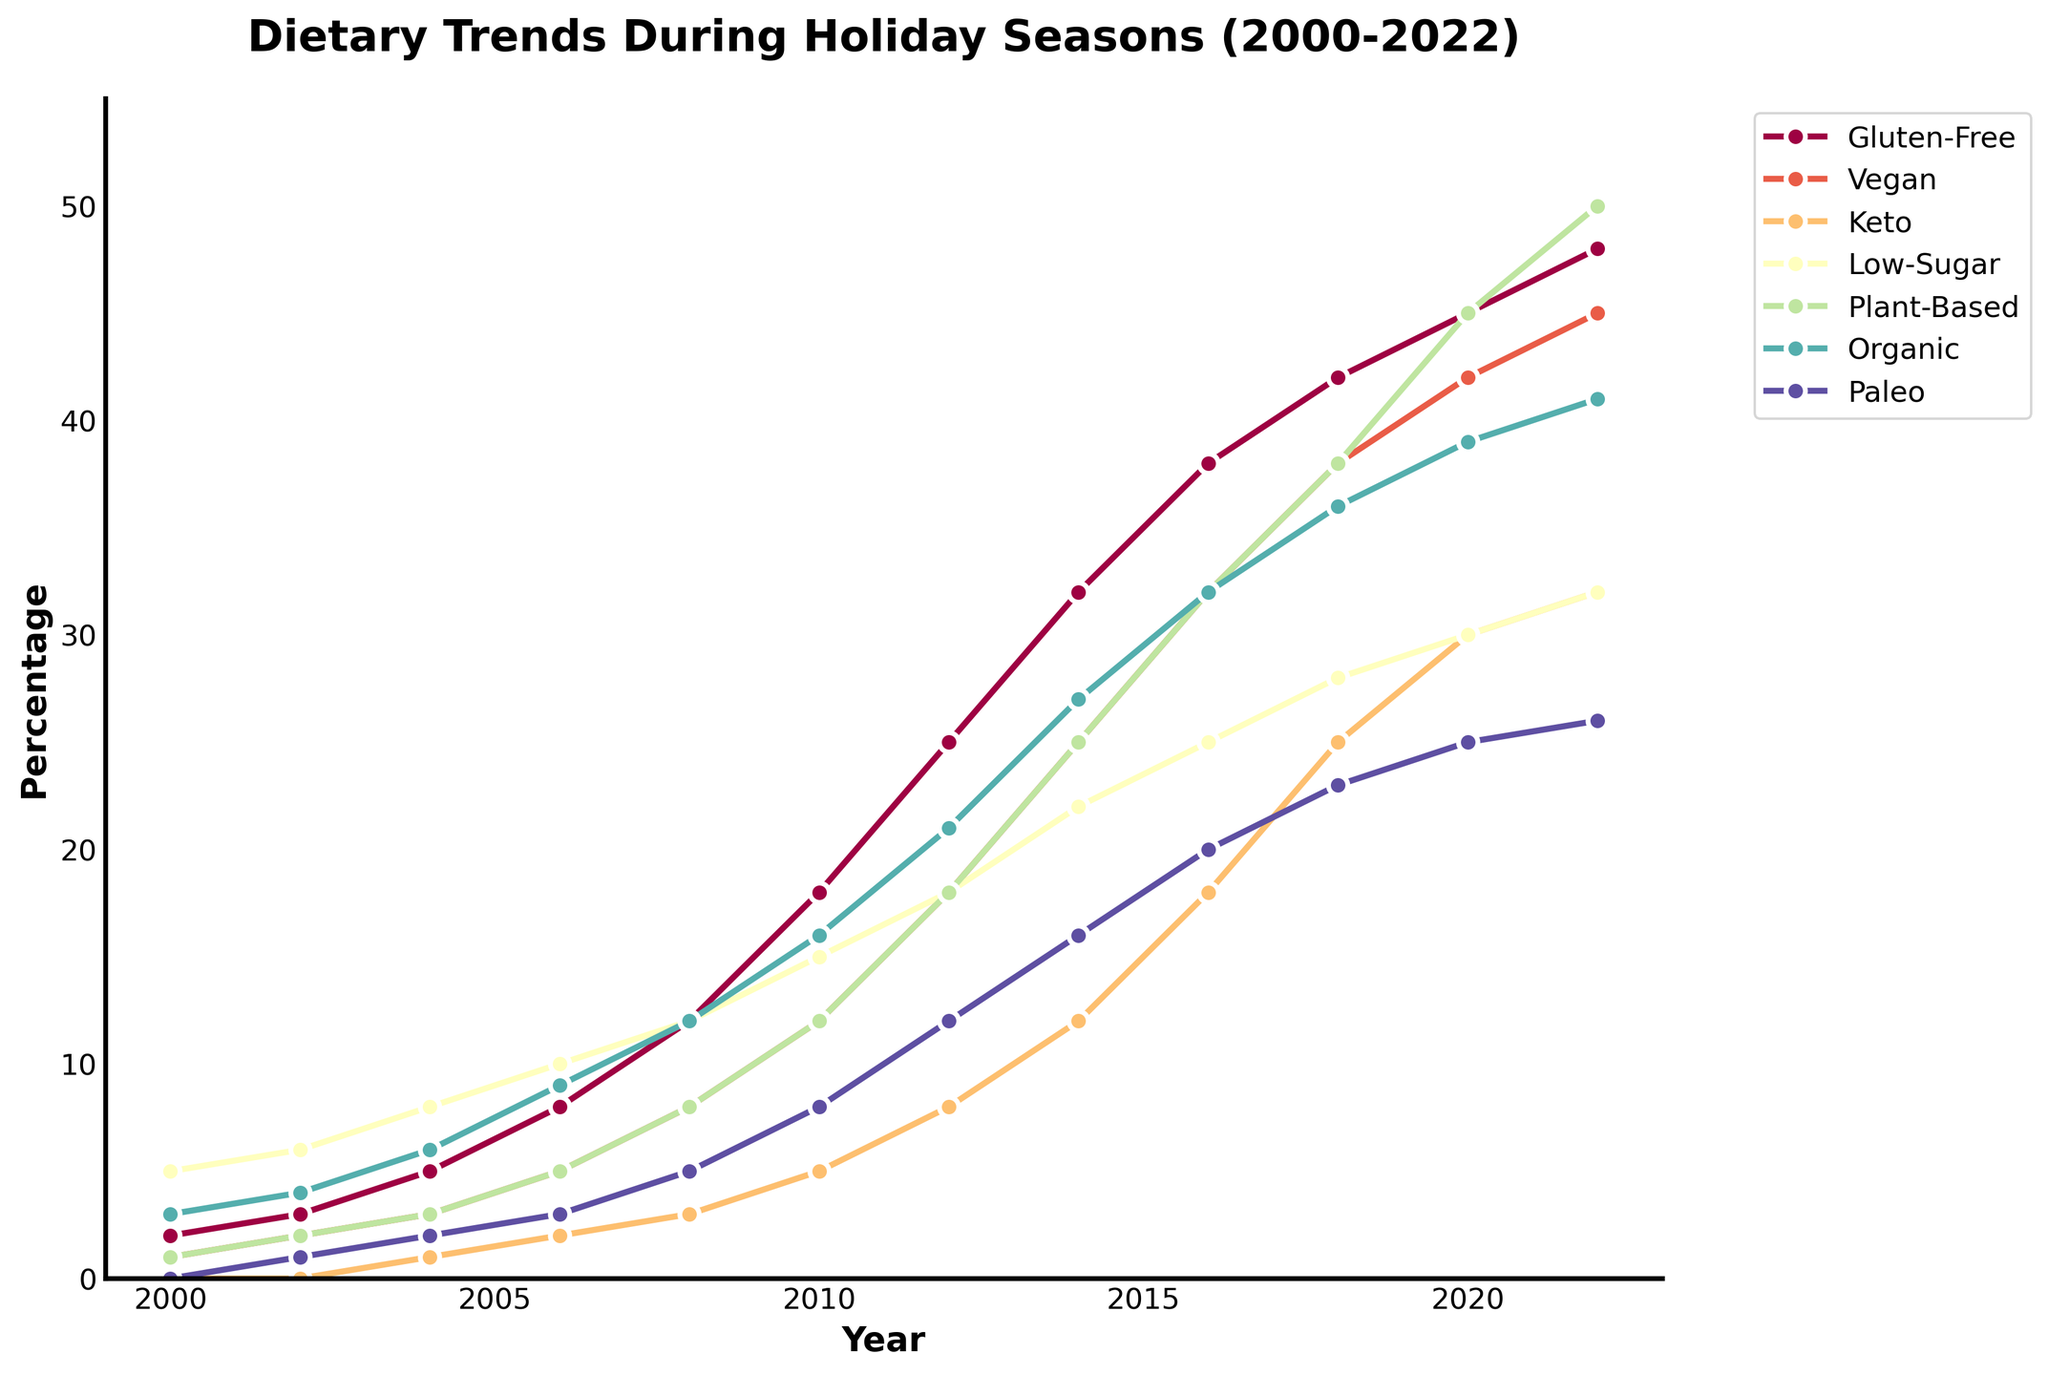What year did the Gluten-Free trend surpass 40%? The figure shows the Gluten-Free trend rising steadily, and it surpasses the 40% mark around 2018. Look for the point where the Gluten-Free line crosses above 40%.
Answer: 2018 Which dietary restriction showed the greatest increase from 2000 to 2022? By comparing the initial and final percentages of each restriction from the figure, the most significant increase is seen in the Plant-Based trend (from 1% in 2000 to 50% in 2022).
Answer: Plant-Based In which year did the Vegan trend reach the same percentage as the Low-Sugar trend in 2010? The Low-Sugar trend is approximately 15% in 2010. Check the Vegan line to find the year it first reaches 15%.
Answer: 2012 Which dietary preference maintained a consistent upward trend without any significant decline throughout the given period? Observing the lines in the figure, the Gluten-Free trend shows a consistent increase without any significant drop from 2000 to 2022.
Answer: Gluten-Free How many dietary trends reached at least 25% in 2022? Check the percentages of all dietary trends in 2022. Gluten-Free, Vegan, Keto, Plant-Based, and Organic all reached at least 25%.
Answer: 5 What was the difference in the percentage points of the Plant-Based trend between 2006 and 2016? The percentage for Plant-Based is 5% in 2006 and rises to 32% in 2016. The difference is calculated as 32% - 5% = 27%.
Answer: 27 Which year witnessed the highest percentage increase in Organic preferences? The Organic trend shows a jump from 3% in 2000 to 4% in 2002, but the largest increase is between 2004 and 2006, from 6% to 9%. The latter increase by 3 percentage points is the highest.
Answer: 2006 Compare the growth trends of Vegan and Paleo diets from 2008 to 2022. Which grew faster? The Vegan trend goes from 8% in 2008 to 45% in 2022, a 37 percentage point increase. Paleo starts at 5% in 2008 and reaches 26% in 2022, a 21 percentage point increase. Faster growth is observed for the Vegan trend.
Answer: Vegan Was there any point where the percentage of Keto dietary preferences decreased? Trace the Keto line from 2000 to 2022 in the figure. All segments indicate an upward trend without decline.
Answer: No 